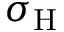<formula> <loc_0><loc_0><loc_500><loc_500>\sigma _ { \mathrm H }</formula> 